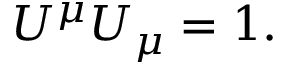<formula> <loc_0><loc_0><loc_500><loc_500>U ^ { \mu } U _ { \mu } = 1 .</formula> 